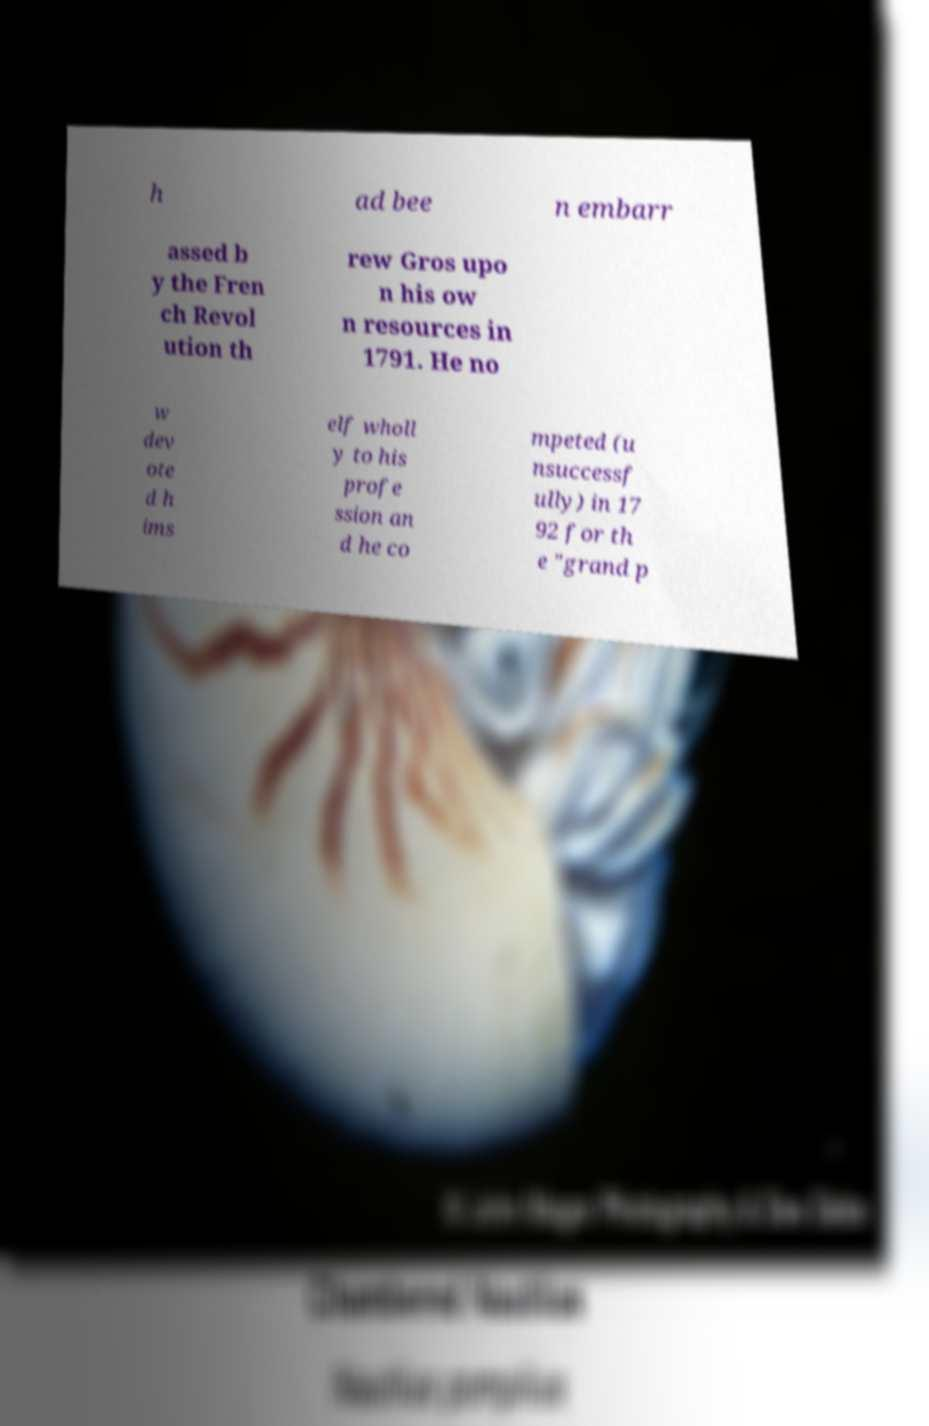Please read and relay the text visible in this image. What does it say? h ad bee n embarr assed b y the Fren ch Revol ution th rew Gros upo n his ow n resources in 1791. He no w dev ote d h ims elf wholl y to his profe ssion an d he co mpeted (u nsuccessf ully) in 17 92 for th e "grand p 